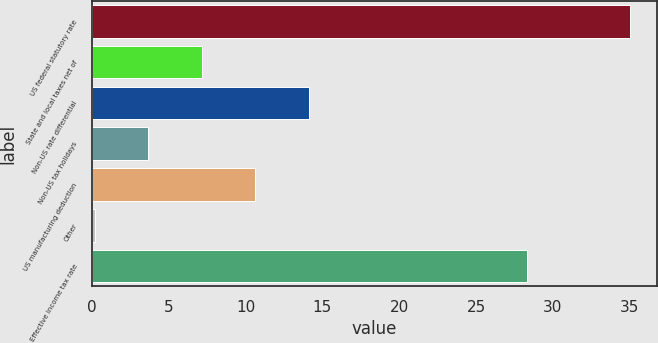<chart> <loc_0><loc_0><loc_500><loc_500><bar_chart><fcel>US federal statutory rate<fcel>State and local taxes net of<fcel>Non-US rate differential<fcel>Non-US tax holidays<fcel>US manufacturing deduction<fcel>Other<fcel>Effective income tax rate<nl><fcel>35<fcel>7.16<fcel>14.12<fcel>3.68<fcel>10.64<fcel>0.2<fcel>28.3<nl></chart> 